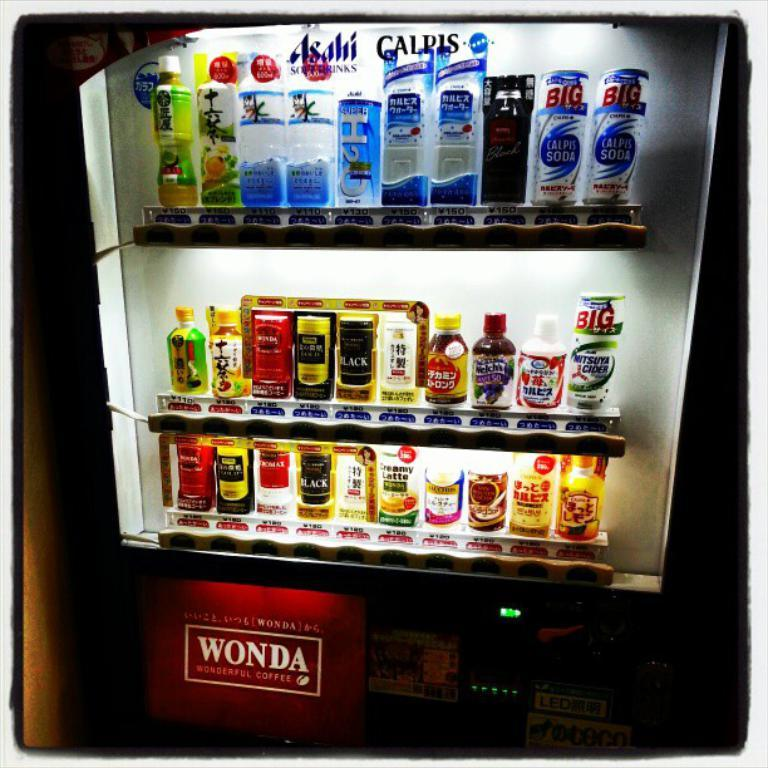<image>
Render a clear and concise summary of the photo. A vending machine offers beverages from Asahi soft drinks and Calpis. 